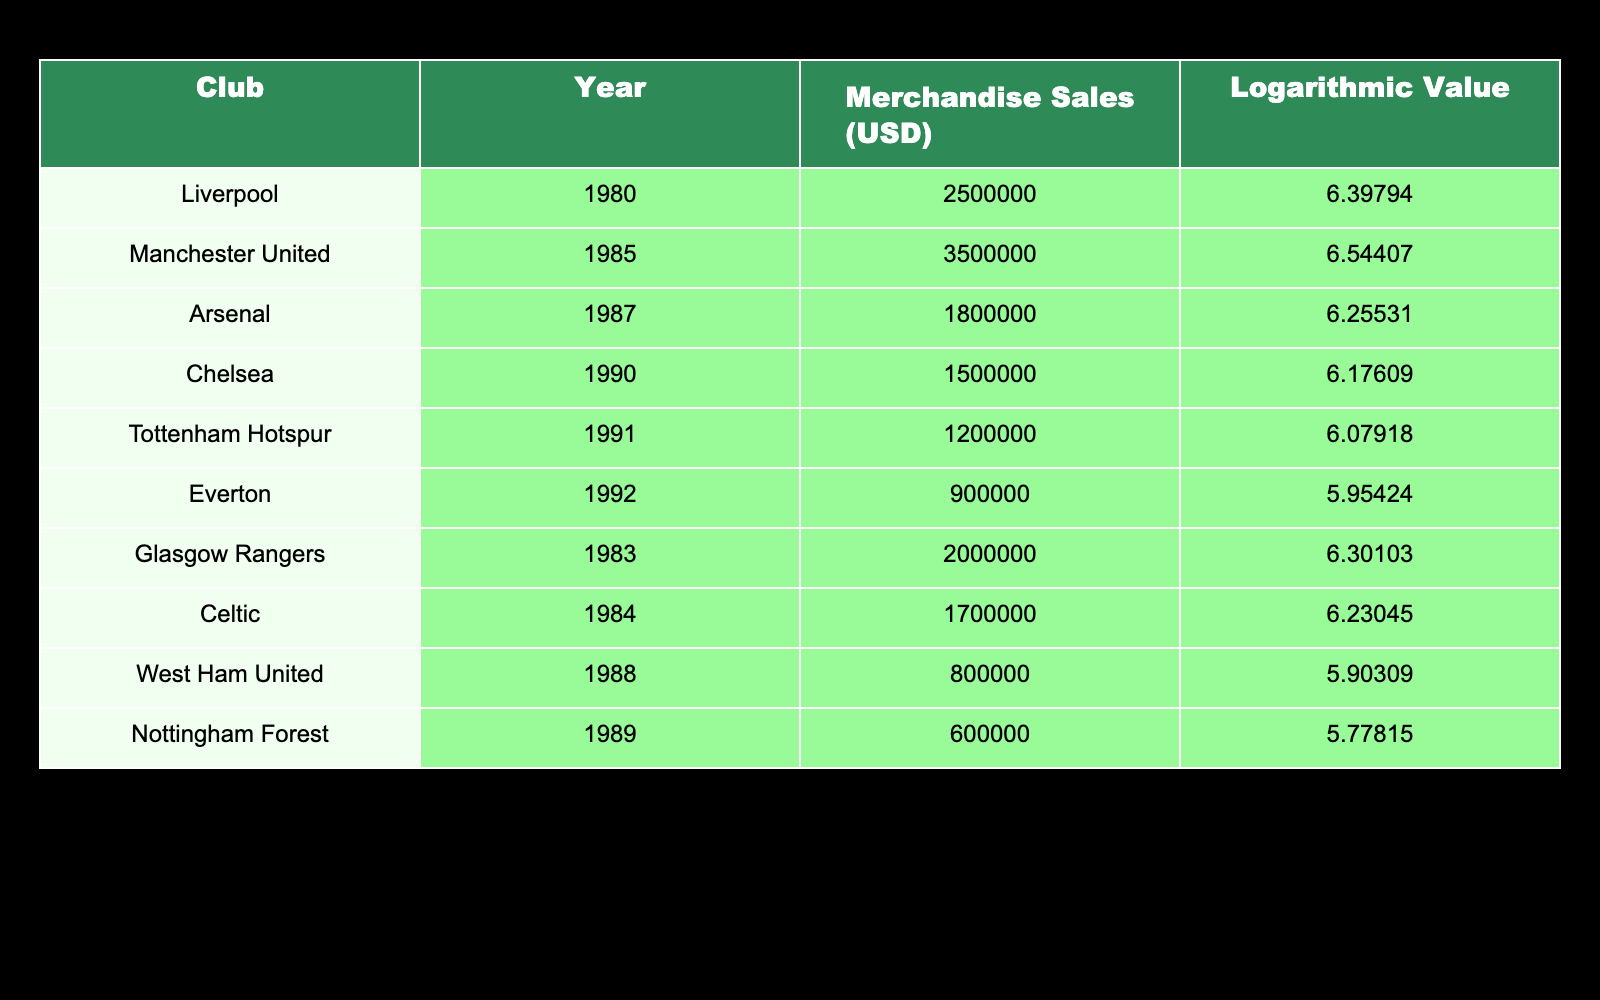What was the merchandise sales figure for Liverpool in 1980? According to the table, Liverpool's merchandise sales in 1980 amounted to 2,500,000 USD.
Answer: 2,500,000 USD Which club had the highest merchandise sales in 1985? By checking the table, Manchester United had the highest merchandise sales in 1985 with a total of 3,500,000 USD.
Answer: Manchester United What is the total merchandise sales for Arsenal and Chelsea combined? To find the total, we take Arsenal's sales of 1,800,000 USD and Chelsea's sales of 1,500,000 USD, then add them together: 1,800,000 + 1,500,000 = 3,300,000 USD.
Answer: 3,300,000 USD Was the merchandise sales for Everton in 1992 greater than 1,000,000 USD? According to the table, Everton's merchandise sales in 1992 were 900,000 USD, which is less than 1,000,000 USD.
Answer: No What was the average merchandise sales across all clubs listed for the year 1987? The merchandise sales figures from the table for 1987 include only Arsenal with 1,800,000 USD. Since this is the only entry, the average remains the same: 1,800,000 USD/1 = 1,800,000 USD.
Answer: 1,800,000 USD How many clubs had merchandise sales lower than 1,000,000 USD? From the table, Everton with 900,000 USD, West Ham United with 800,000 USD, and Nottingham Forest with 600,000 USD are the clubs below 1,000,000 USD. Therefore, there are three clubs.
Answer: 3 Which year saw the lowest merchandise sales for the listed clubs, and what is that figure? By examining the table, Nottingham Forest in 1989 had the lowest merchandise sales with a figure of 600,000 USD.
Answer: 1989, 600,000 USD If we look at sales in logarithmic values, which club had the lowest value and what was it? From the table, Nottingham Forest in 1989 had the lowest logarithmic value of 5.77815.
Answer: Nottingham Forest, 5.77815 